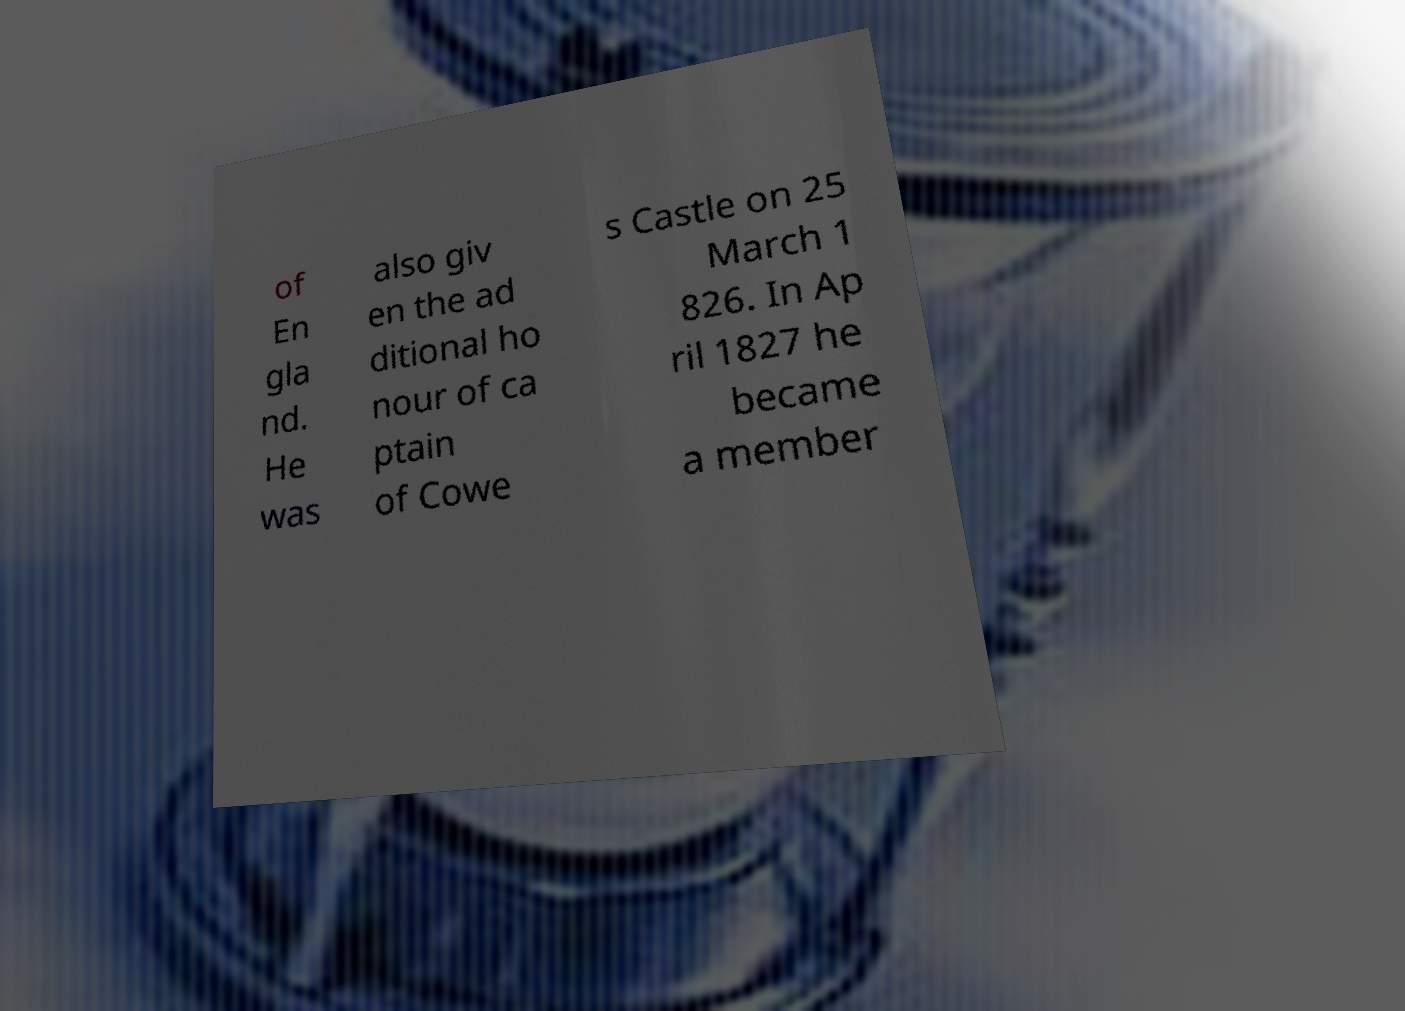For documentation purposes, I need the text within this image transcribed. Could you provide that? of En gla nd. He was also giv en the ad ditional ho nour of ca ptain of Cowe s Castle on 25 March 1 826. In Ap ril 1827 he became a member 